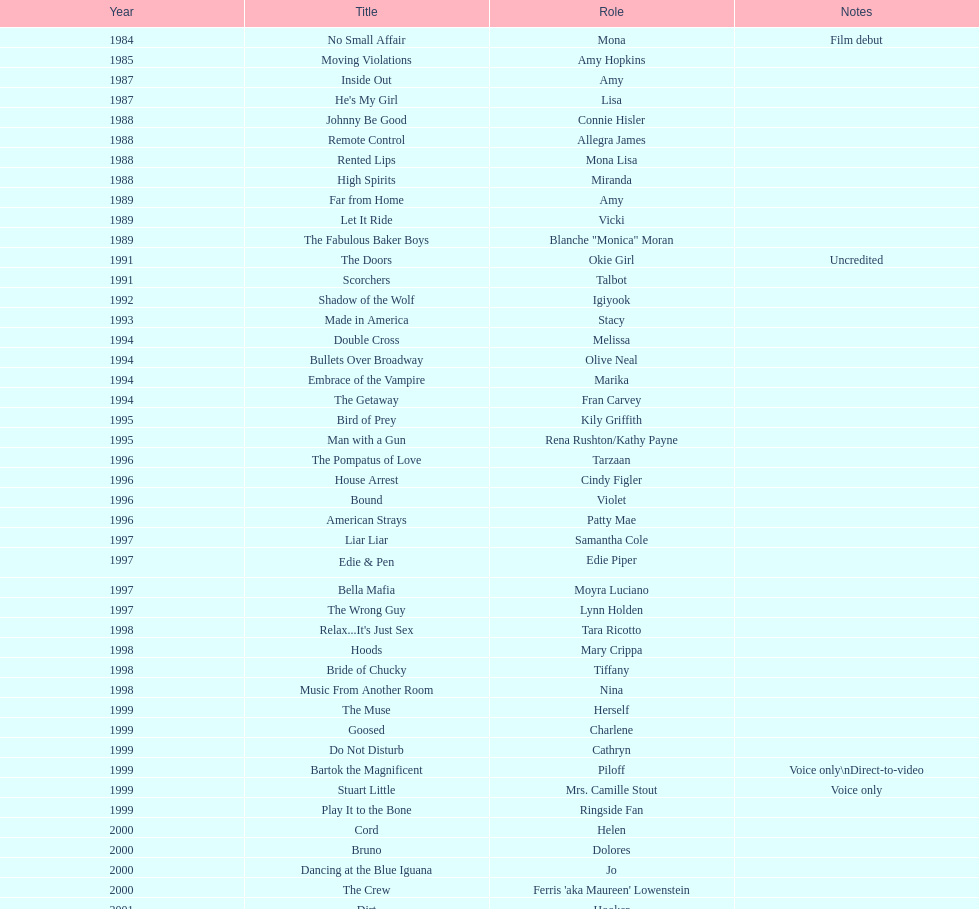Parse the full table. {'header': ['Year', 'Title', 'Role', 'Notes'], 'rows': [['1984', 'No Small Affair', 'Mona', 'Film debut'], ['1985', 'Moving Violations', 'Amy Hopkins', ''], ['1987', 'Inside Out', 'Amy', ''], ['1987', "He's My Girl", 'Lisa', ''], ['1988', 'Johnny Be Good', 'Connie Hisler', ''], ['1988', 'Remote Control', 'Allegra James', ''], ['1988', 'Rented Lips', 'Mona Lisa', ''], ['1988', 'High Spirits', 'Miranda', ''], ['1989', 'Far from Home', 'Amy', ''], ['1989', 'Let It Ride', 'Vicki', ''], ['1989', 'The Fabulous Baker Boys', 'Blanche "Monica" Moran', ''], ['1991', 'The Doors', 'Okie Girl', 'Uncredited'], ['1991', 'Scorchers', 'Talbot', ''], ['1992', 'Shadow of the Wolf', 'Igiyook', ''], ['1993', 'Made in America', 'Stacy', ''], ['1994', 'Double Cross', 'Melissa', ''], ['1994', 'Bullets Over Broadway', 'Olive Neal', ''], ['1994', 'Embrace of the Vampire', 'Marika', ''], ['1994', 'The Getaway', 'Fran Carvey', ''], ['1995', 'Bird of Prey', 'Kily Griffith', ''], ['1995', 'Man with a Gun', 'Rena Rushton/Kathy Payne', ''], ['1996', 'The Pompatus of Love', 'Tarzaan', ''], ['1996', 'House Arrest', 'Cindy Figler', ''], ['1996', 'Bound', 'Violet', ''], ['1996', 'American Strays', 'Patty Mae', ''], ['1997', 'Liar Liar', 'Samantha Cole', ''], ['1997', 'Edie & Pen', 'Edie Piper', ''], ['1997', 'Bella Mafia', 'Moyra Luciano', ''], ['1997', 'The Wrong Guy', 'Lynn Holden', ''], ['1998', "Relax...It's Just Sex", 'Tara Ricotto', ''], ['1998', 'Hoods', 'Mary Crippa', ''], ['1998', 'Bride of Chucky', 'Tiffany', ''], ['1998', 'Music From Another Room', 'Nina', ''], ['1999', 'The Muse', 'Herself', ''], ['1999', 'Goosed', 'Charlene', ''], ['1999', 'Do Not Disturb', 'Cathryn', ''], ['1999', 'Bartok the Magnificent', 'Piloff', 'Voice only\\nDirect-to-video'], ['1999', 'Stuart Little', 'Mrs. Camille Stout', 'Voice only'], ['1999', 'Play It to the Bone', 'Ringside Fan', ''], ['2000', 'Cord', 'Helen', ''], ['2000', 'Bruno', 'Dolores', ''], ['2000', 'Dancing at the Blue Iguana', 'Jo', ''], ['2000', 'The Crew', "Ferris 'aka Maureen' Lowenstein", ''], ['2001', 'Dirt', 'Hooker', ''], ['2001', 'Fast Sofa', 'Ginger Quail', ''], ['2001', 'Monsters, Inc.', 'Celia Mae', 'Voice only'], ['2001', 'Ball in the House', 'Dot', ''], ['2001', "The Cat's Meow", 'Louella Parsons', ''], ['2003', 'Hollywood North', 'Gillian Stevens', ''], ['2003', 'The Haunted Mansion', 'Madame Leota', ''], ['2003', 'Happy End', 'Edna', ''], ['2003', 'Jericho Mansions', 'Donna Cherry', ''], ['2004', 'Second Best', 'Carole', ''], ['2004', 'Perfect Opposites', 'Elyse Steinberg', ''], ['2004', 'Home on the Range', 'Grace', 'Voice only'], ['2004', 'El Padrino', 'Sebeva', ''], ['2004', 'Saint Ralph', 'Nurse Alice', ''], ['2004', 'Love on the Side', 'Alma Kerns', ''], ['2004', 'Seed of Chucky', 'Tiffany/Herself', ''], ['2005', "Bailey's Billion$", 'Dolores Pennington', ''], ['2005', "Lil' Pimp", 'Miss De La Croix', 'Voice only'], ['2005', 'The Civilization of Maxwell Bright', "Dr. O'Shannon", ''], ['2005', 'Tideland', 'Queen Gunhilda', ''], ['2006', 'The Poker Movie', 'Herself', ''], ['2007', 'Intervention', '', ''], ['2008', 'Deal', "Karen 'Razor' Jones", ''], ['2008', 'The Caretaker', 'Miss Perry', ''], ['2008', 'Bart Got a Room', 'Melinda', ''], ['2008', 'Inconceivable', "Salome 'Sally' Marsh", ''], ['2009', 'An American Girl: Chrissa Stands Strong', 'Mrs. Rundell', ''], ['2009', 'Imps', '', ''], ['2009', 'Made in Romania', 'Herself', ''], ['2009', 'Empire of Silver', 'Mrs. Landdeck', ''], ['2010', 'The Making of Plus One', 'Amber', ''], ['2010', 'The Secret Lives of Dorks', 'Ms. Stewart', ''], ['2012', '30 Beats', 'Erika', ''], ['2013', 'Curse of Chucky', 'Tiffany Ray', 'Cameo, Direct-to-video']]} How many rolls did jennifer tilly play in the 1980s? 11. 